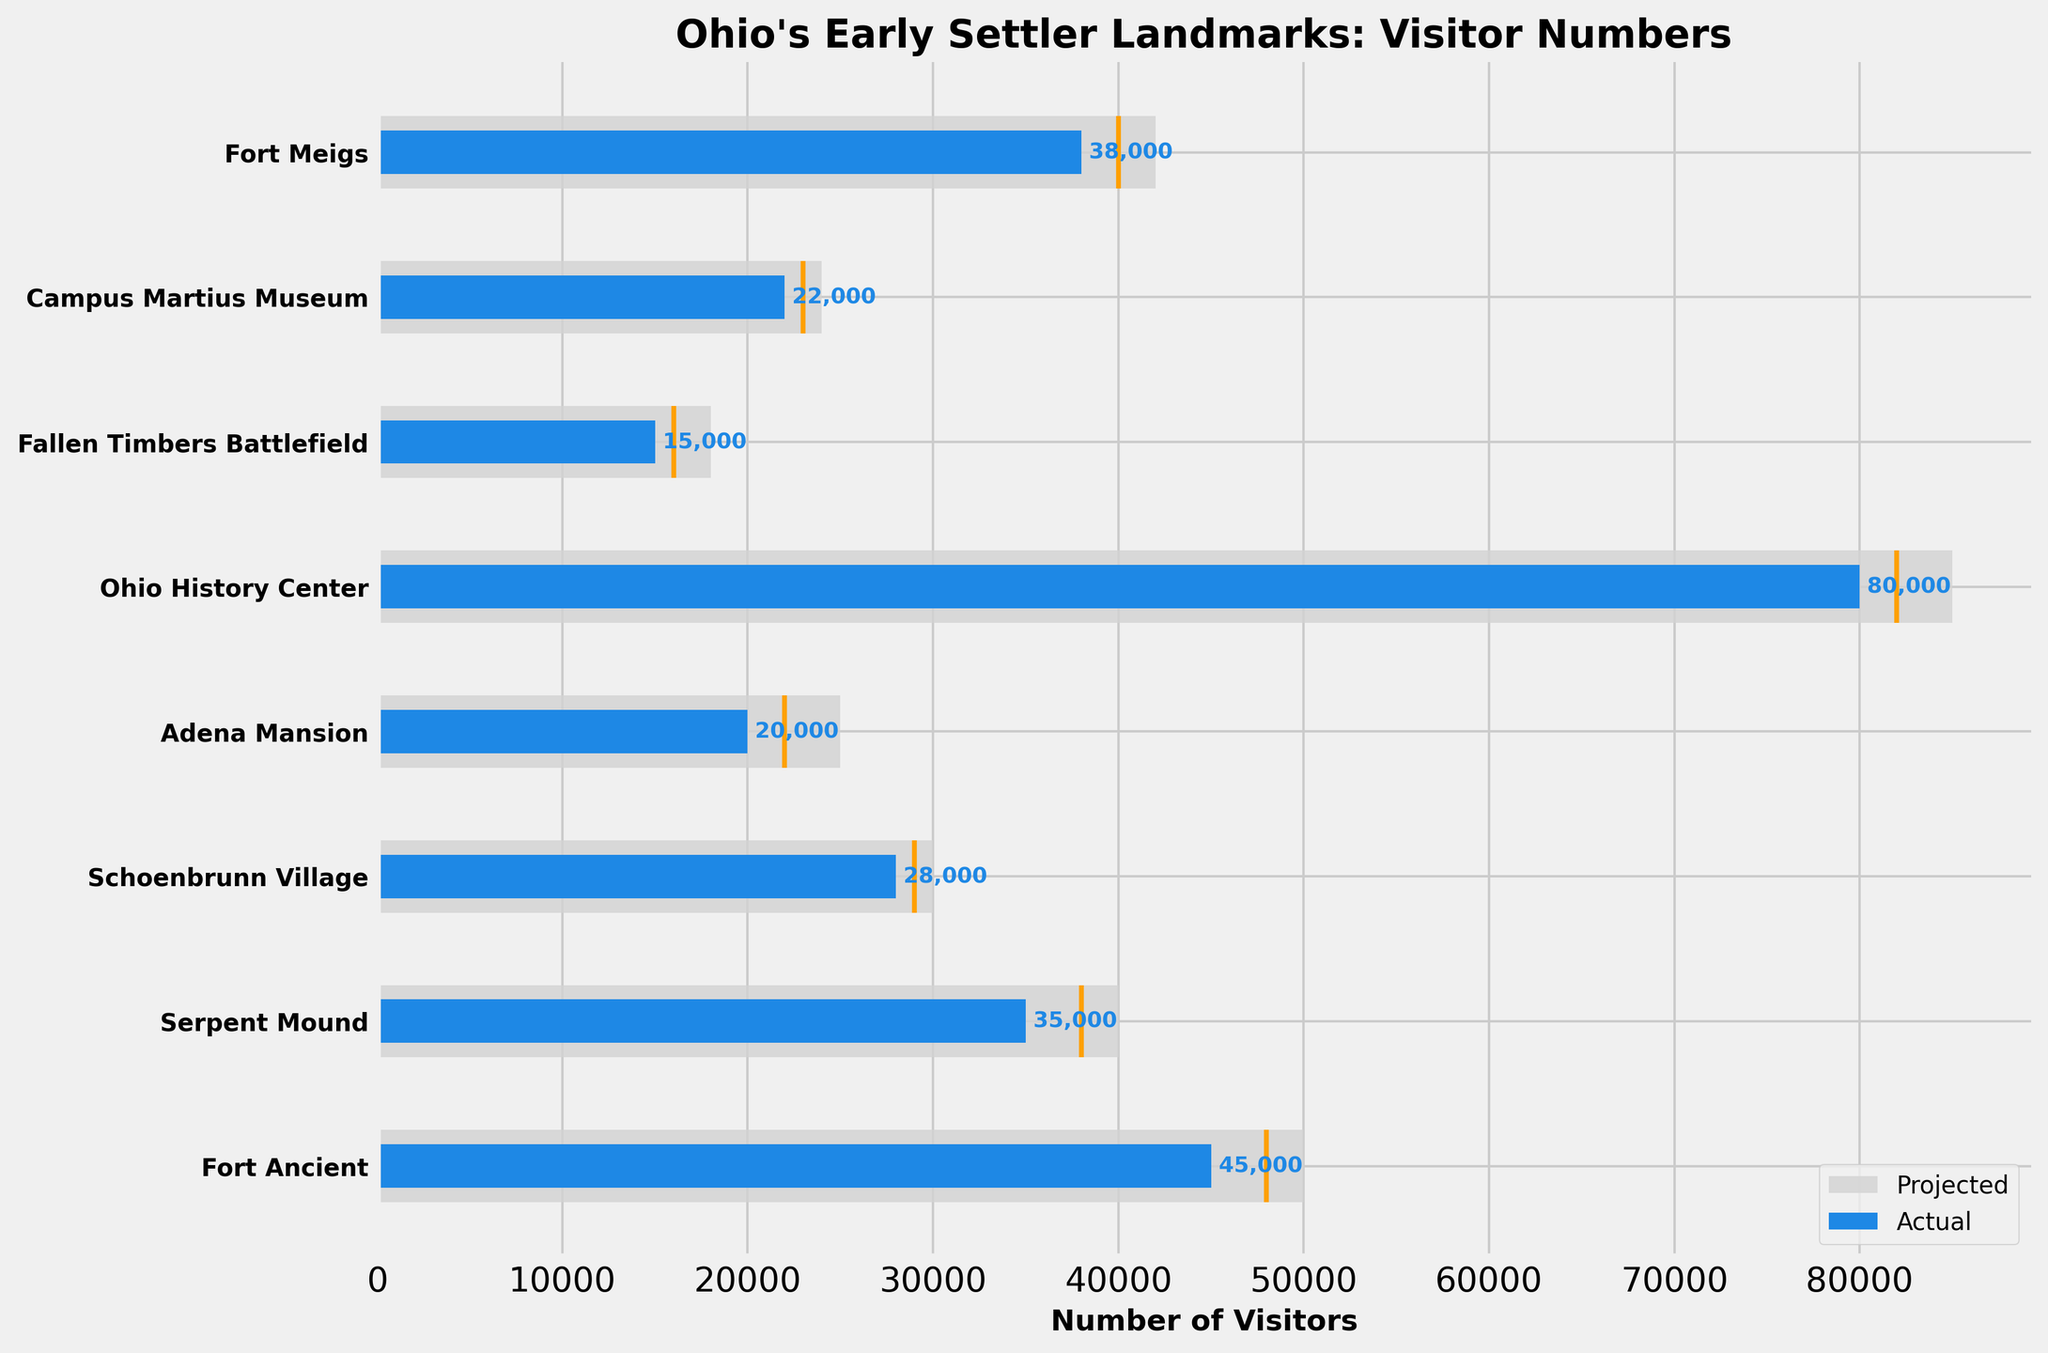What is the title of the plot? The title is usually displayed prominently at the top of the plot. Here, the title is "Ohio's Early Settler Landmarks: Visitor Numbers".
Answer: Ohio's Early Settler Landmarks: Visitor Numbers How many landmarks are included in the plot? The plot shows a horizontal bar for each landmark, and there are 8 landmarks displayed.
Answer: 8 Which landmark had the most actual visitors? The tallest blue bar represents the site with the most actual visitors. Ohio History Center has the tallest blue bar with 80,000 visitors.
Answer: Ohio History Center Are there any landmarks where the actual visitors exceed the projected visitors? By comparing the lengths of the blue bars (actual visitors) to the grey bars (projected visitors), we can check each site. None of the blue bars exceed the grey bars, indicating that none of the actual visitor numbers exceed the projected numbers.
Answer: No What is the historical average of visitors for Schoenbrunn Village? The historical average is represented by the yellow line in the plot. For Schoenbrunn Village, the yellow line is positioned at 29,000 visitors.
Answer: 29,000 Which landmark came closest to meeting its projected visitor numbers? By comparing the length of each blue bar (actual) to its corresponding grey bar (projected), we find that Ohio History Center, with 80,000 actual vs. 85,000 projected, has the smallest difference.
Answer: Ohio History Center What is the difference between actual and projected visitors for Adena Mansion? To find the difference, subtract the actual visitors (20,000) from the projected visitors (25,000): 25,000 - 20,000. This gives a difference of 5,000 visitors.
Answer: 5,000 How does the actual visitor number for Serpent Mound compare to its historical average? The actual visitors (blue bar) is 35,000 while the historical average (yellow line) is 38,000. Since 35,000 is less than 38,000, the actual number falls short of the historical average.
Answer: Less Which landmark has the smallest difference between its actual visitors and historical average? By checking the gap between the blue bar and the yellow line for each landmark, Adena Mansion has the smallest difference (2,000), with actual visitors at 20,000 and historical average at 22,000.
Answer: Adena Mansion For how many landmarks is the actual visitor count below the historical average? Compare the position of the blue bars to the yellow lines for each landmark. There are 4 landmarks where the actual visitors are below the historical average: Fort Meigs, Serpent Mound, Fallen Timbers Battlefield, and Campus Martius Museum.
Answer: 4 